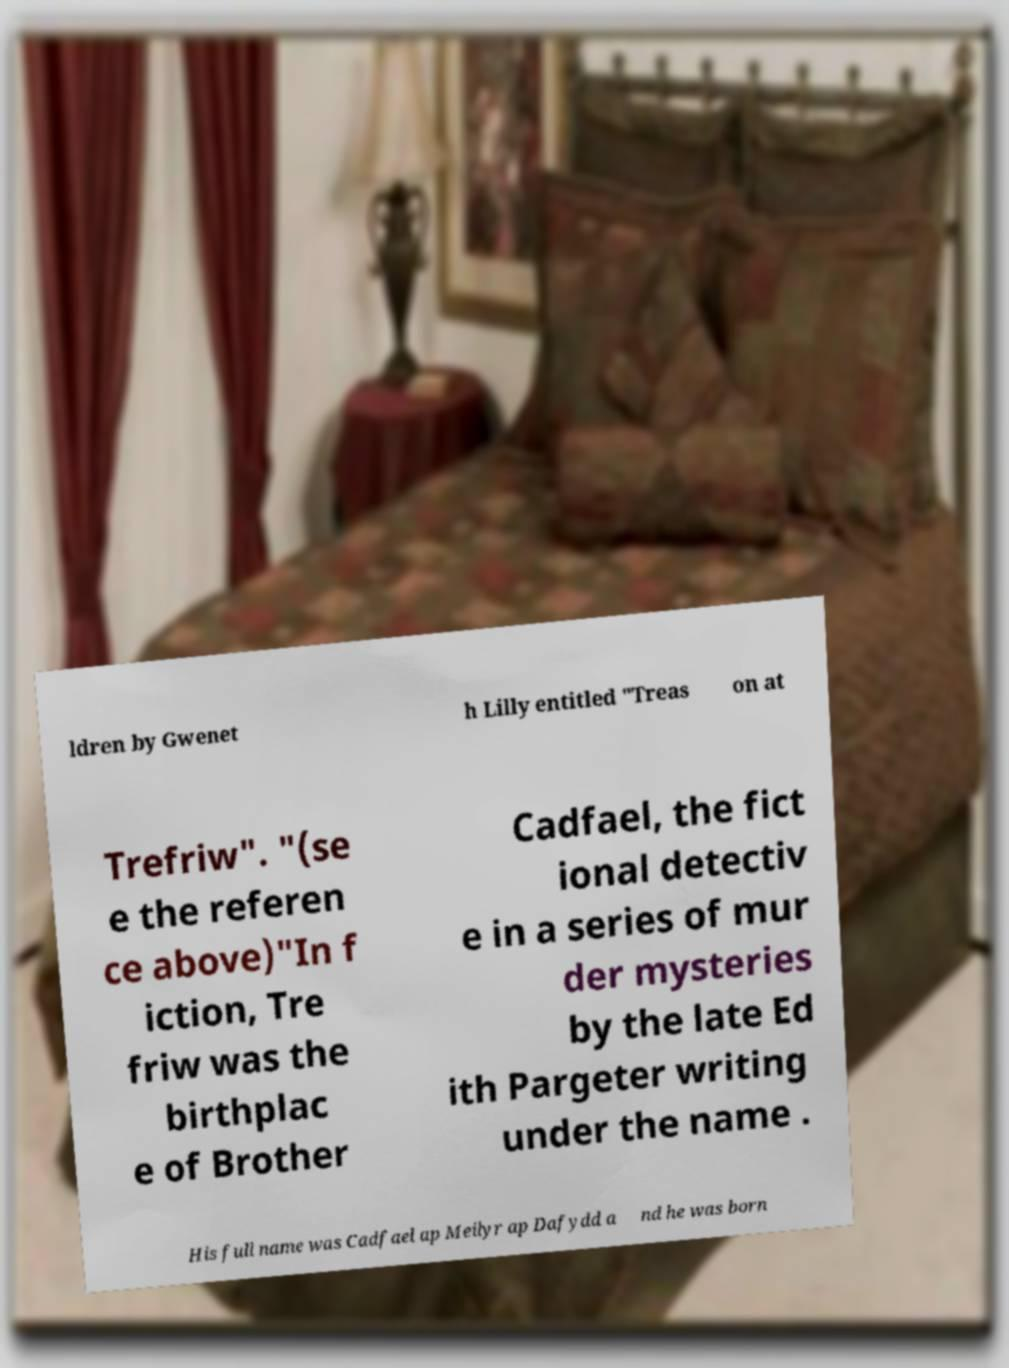Can you accurately transcribe the text from the provided image for me? ldren by Gwenet h Lilly entitled "Treas on at Trefriw". "(se e the referen ce above)"In f iction, Tre friw was the birthplac e of Brother Cadfael, the fict ional detectiv e in a series of mur der mysteries by the late Ed ith Pargeter writing under the name . His full name was Cadfael ap Meilyr ap Dafydd a nd he was born 